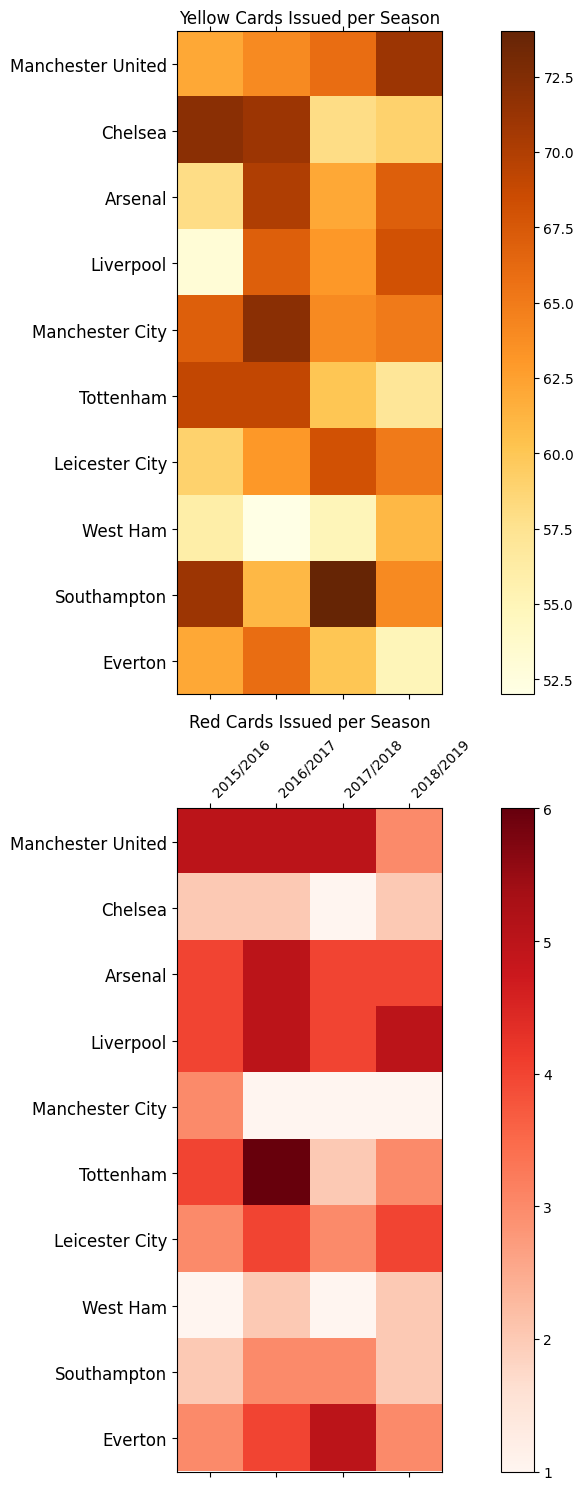Which team received the most yellow cards in the 2016/2017 season? Refer to the top heatmap for yellow cards and locate the brightest or most intense square for the 2016/2017 season. The team that corresponds to this square is the one that received the most yellow cards.
Answer: Liverpool Compare the red cards received by Arsenal and Manchester City in the 2017/2018 season. Which team had more, and by how much? Look at the heatmap for red cards and find the values for Arsenal and Manchester City in the 2017/2018 season. Arsenal received 5 red cards, and Manchester City received 2 red cards. The difference is calculated by subtracting the smaller value from the larger value (5 - 2 = 3).
Answer: Arsenal had 3 more red cards than Manchester City Which seasons did Tottenham receive more than 70 yellow cards? Refer to the yellow card heatmap and find the rows corresponding to Tottenham. Check the data across all seasons for cells with values greater than 70.
Answer: 2015/2016 and 2017/2018 What is the average number of red cards issued to Southampton over the four seasons? Find the values for Southampton in the red cards heatmap for each season: 1 (2015/2016), 2 (2016/2017), 1 (2017/2018), and 2 (2018/2019). Calculate the sum and divide by the number of seasons: (1+2+1+2)/4 = 1.5.
Answer: 1.5 Did any team have zero red cards in any of the seasons? Look at the red card heatmap to check all cells across all seasons and teams. Identify if any cell has a value of zero.
Answer: No Which season had the highest total of yellow cards for Manchester United? Check the yellow card heatmap for Manchester United across all seasons. Note down the values: 59 (2015/2016), 63 (2016/2017), 68 (2017/2018), and 65 (2018/2019). Determine the highest value among them.
Answer: 2017/2018 In which season did Leicester City receive their maximum number of red cards? Refer to the red card heatmap and locate the row corresponding to Leicester City. Check the values across all seasons and identify the highest number.
Answer: 2018/2019 Which team showed a significant reduction in the number of yellow cards from 2016/2017 to 2017/2018? Compare the number of yellow cards in the yellow card heatmap for all teams between the 2016/2017 and 2017/2018 seasons. Identify any team with a noticeable decrease in yellow cards.
Answer: Chelsea (71 to 58) How did the discipline (in terms of red cards) change for Everton from the earliest to the latest season? Analyze the red card heatmap for Everton from the earliest (2015/2016) to the latest season (2018/2019). Note the values: 4 (2015/2016), 5 (2016/2017), 4 (2017/2018), and 4 (2018/2019). Compare the earliest and latest values.
Answer: Unchanged (4 to 4) Did Liverpool improve their discipline in terms of yellow cards from 2016/2017 to 2018/2019? Check the yellow card heatmap for Liverpool for the 2016/2017 and 2018/2019 seasons. Note the values 72 (2016/2017) and 65 (2018/2019). A decrease in the number indicates an improvement.
Answer: Yes, improved 